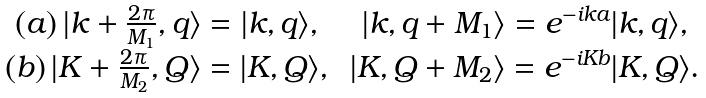Convert formula to latex. <formula><loc_0><loc_0><loc_500><loc_500>\begin{array} { c c } ( a ) \, | k + \frac { 2 \pi } { M _ { 1 } } , q \rangle = | k , q \rangle , \, & | k , q + M _ { 1 } \rangle = e ^ { - i k a } | k , q \rangle , \\ ( b ) \, | K + \frac { 2 \pi } { M _ { 2 } } , Q \rangle = | K , Q \rangle , \, & | K , Q + M _ { 2 } \rangle = e ^ { - i K b } | K , Q \rangle . \end{array}</formula> 